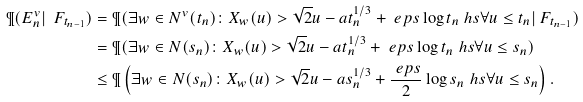Convert formula to latex. <formula><loc_0><loc_0><loc_500><loc_500>\P ( E ^ { v } _ { n } | \ F _ { t _ { n - 1 } } ) & = \P ( \exists w \in N ^ { v } ( t _ { n } ) \colon X _ { w } ( u ) > \sqrt { 2 } u - a t _ { n } ^ { 1 / 3 } + \ e p s \log t _ { n } \ h s \forall u \leq t _ { n } | \ F _ { t _ { n - 1 } } ) \\ & = \P ( \exists w \in N ( s _ { n } ) \colon X _ { w } ( u ) > \sqrt { 2 } u - a t _ { n } ^ { 1 / 3 } + \ e p s \log t _ { n } \ h s \forall u \leq s _ { n } ) \\ & \leq \P \left ( \exists w \in N ( s _ { n } ) \colon X _ { w } ( u ) > \sqrt { 2 } u - a s _ { n } ^ { 1 / 3 } + \frac { \ e p s } { 2 } \log s _ { n } \ h s \forall u \leq s _ { n } \right ) .</formula> 